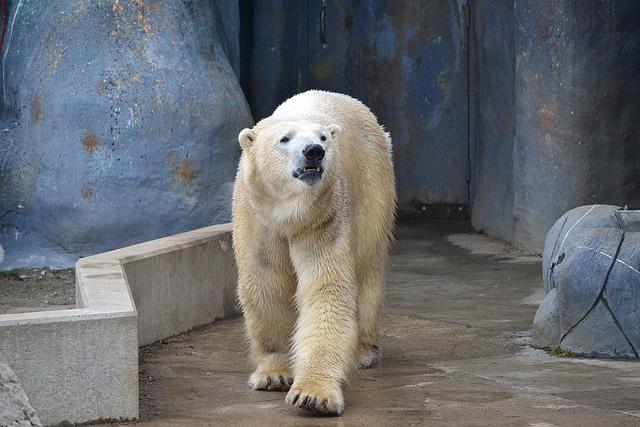What animal is this?
Short answer required. Polar bear. Is this animal in the wild?
Concise answer only. No. Is this bear an endangered species?
Concise answer only. Yes. How many bears are there?
Be succinct. 1. Is the bear standing?
Keep it brief. Yes. 